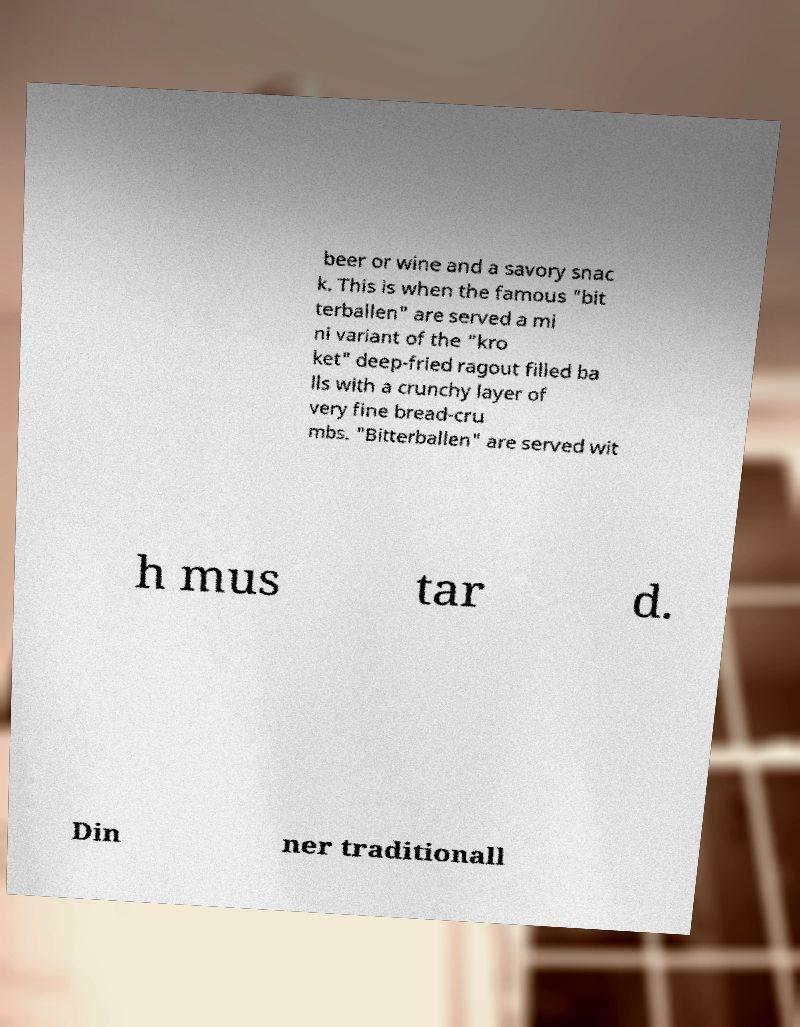Can you read and provide the text displayed in the image?This photo seems to have some interesting text. Can you extract and type it out for me? beer or wine and a savory snac k. This is when the famous "bit terballen" are served a mi ni variant of the "kro ket" deep-fried ragout filled ba lls with a crunchy layer of very fine bread-cru mbs. "Bitterballen" are served wit h mus tar d. Din ner traditionall 